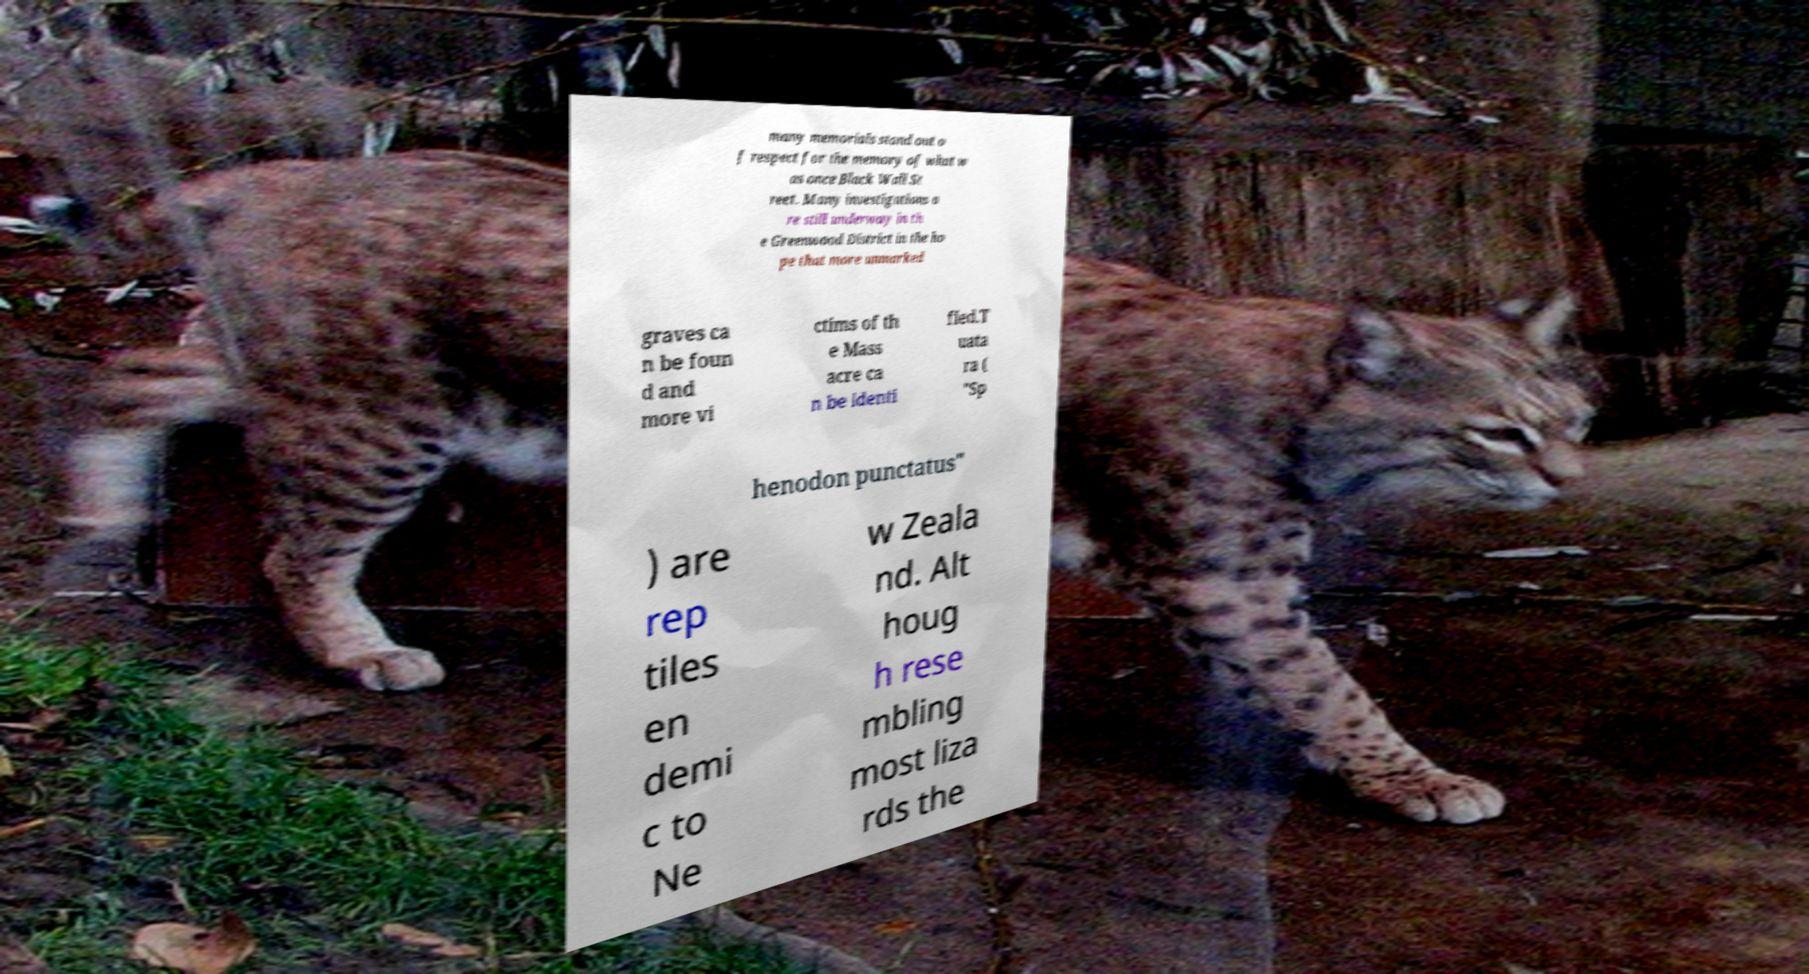Please identify and transcribe the text found in this image. many memorials stand out o f respect for the memory of what w as once Black Wall St reet. Many investigations a re still underway in th e Greenwood District in the ho pe that more unmarked graves ca n be foun d and more vi ctims of th e Mass acre ca n be identi fied.T uata ra ( "Sp henodon punctatus" ) are rep tiles en demi c to Ne w Zeala nd. Alt houg h rese mbling most liza rds the 